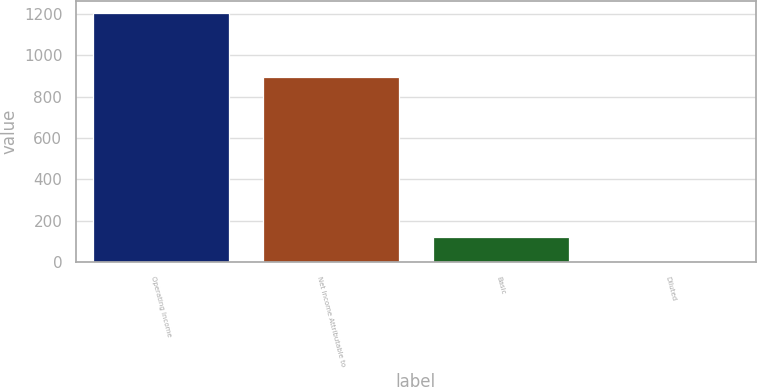<chart> <loc_0><loc_0><loc_500><loc_500><bar_chart><fcel>Operating Income<fcel>Net Income Attributable to<fcel>Basic<fcel>Diluted<nl><fcel>1202.6<fcel>896.8<fcel>123.72<fcel>3.85<nl></chart> 